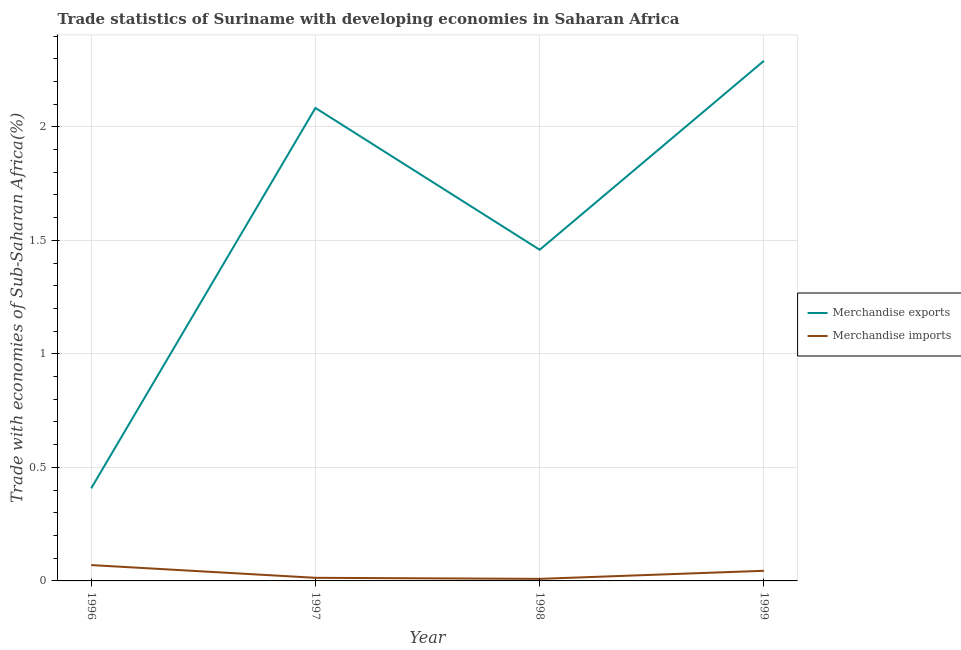What is the merchandise imports in 1998?
Offer a very short reply. 0.01. Across all years, what is the maximum merchandise imports?
Provide a short and direct response. 0.07. Across all years, what is the minimum merchandise exports?
Provide a short and direct response. 0.41. In which year was the merchandise exports minimum?
Keep it short and to the point. 1996. What is the total merchandise imports in the graph?
Give a very brief answer. 0.14. What is the difference between the merchandise imports in 1996 and that in 1997?
Keep it short and to the point. 0.06. What is the difference between the merchandise exports in 1999 and the merchandise imports in 1997?
Keep it short and to the point. 2.28. What is the average merchandise imports per year?
Provide a succinct answer. 0.03. In the year 1997, what is the difference between the merchandise imports and merchandise exports?
Offer a terse response. -2.07. In how many years, is the merchandise imports greater than 0.8 %?
Provide a short and direct response. 0. What is the ratio of the merchandise imports in 1996 to that in 1997?
Your answer should be compact. 5.1. Is the merchandise exports in 1998 less than that in 1999?
Provide a short and direct response. Yes. What is the difference between the highest and the second highest merchandise imports?
Offer a terse response. 0.03. What is the difference between the highest and the lowest merchandise exports?
Give a very brief answer. 1.88. In how many years, is the merchandise exports greater than the average merchandise exports taken over all years?
Give a very brief answer. 2. Does the merchandise imports monotonically increase over the years?
Your response must be concise. No. How many lines are there?
Offer a very short reply. 2. How many years are there in the graph?
Offer a terse response. 4. What is the difference between two consecutive major ticks on the Y-axis?
Provide a short and direct response. 0.5. Does the graph contain grids?
Ensure brevity in your answer.  Yes. How are the legend labels stacked?
Your answer should be very brief. Vertical. What is the title of the graph?
Make the answer very short. Trade statistics of Suriname with developing economies in Saharan Africa. What is the label or title of the X-axis?
Keep it short and to the point. Year. What is the label or title of the Y-axis?
Offer a very short reply. Trade with economies of Sub-Saharan Africa(%). What is the Trade with economies of Sub-Saharan Africa(%) of Merchandise exports in 1996?
Provide a short and direct response. 0.41. What is the Trade with economies of Sub-Saharan Africa(%) of Merchandise imports in 1996?
Your answer should be compact. 0.07. What is the Trade with economies of Sub-Saharan Africa(%) in Merchandise exports in 1997?
Keep it short and to the point. 2.08. What is the Trade with economies of Sub-Saharan Africa(%) of Merchandise imports in 1997?
Provide a succinct answer. 0.01. What is the Trade with economies of Sub-Saharan Africa(%) of Merchandise exports in 1998?
Offer a terse response. 1.46. What is the Trade with economies of Sub-Saharan Africa(%) of Merchandise imports in 1998?
Provide a short and direct response. 0.01. What is the Trade with economies of Sub-Saharan Africa(%) in Merchandise exports in 1999?
Make the answer very short. 2.29. What is the Trade with economies of Sub-Saharan Africa(%) in Merchandise imports in 1999?
Provide a succinct answer. 0.04. Across all years, what is the maximum Trade with economies of Sub-Saharan Africa(%) of Merchandise exports?
Give a very brief answer. 2.29. Across all years, what is the maximum Trade with economies of Sub-Saharan Africa(%) of Merchandise imports?
Offer a very short reply. 0.07. Across all years, what is the minimum Trade with economies of Sub-Saharan Africa(%) of Merchandise exports?
Your response must be concise. 0.41. Across all years, what is the minimum Trade with economies of Sub-Saharan Africa(%) in Merchandise imports?
Your response must be concise. 0.01. What is the total Trade with economies of Sub-Saharan Africa(%) in Merchandise exports in the graph?
Your answer should be very brief. 6.24. What is the total Trade with economies of Sub-Saharan Africa(%) of Merchandise imports in the graph?
Provide a short and direct response. 0.14. What is the difference between the Trade with economies of Sub-Saharan Africa(%) in Merchandise exports in 1996 and that in 1997?
Your response must be concise. -1.68. What is the difference between the Trade with economies of Sub-Saharan Africa(%) in Merchandise imports in 1996 and that in 1997?
Keep it short and to the point. 0.06. What is the difference between the Trade with economies of Sub-Saharan Africa(%) of Merchandise exports in 1996 and that in 1998?
Your answer should be very brief. -1.05. What is the difference between the Trade with economies of Sub-Saharan Africa(%) in Merchandise imports in 1996 and that in 1998?
Offer a terse response. 0.06. What is the difference between the Trade with economies of Sub-Saharan Africa(%) of Merchandise exports in 1996 and that in 1999?
Your answer should be very brief. -1.88. What is the difference between the Trade with economies of Sub-Saharan Africa(%) in Merchandise imports in 1996 and that in 1999?
Give a very brief answer. 0.03. What is the difference between the Trade with economies of Sub-Saharan Africa(%) in Merchandise exports in 1997 and that in 1998?
Offer a very short reply. 0.62. What is the difference between the Trade with economies of Sub-Saharan Africa(%) of Merchandise imports in 1997 and that in 1998?
Offer a terse response. 0. What is the difference between the Trade with economies of Sub-Saharan Africa(%) in Merchandise exports in 1997 and that in 1999?
Your response must be concise. -0.21. What is the difference between the Trade with economies of Sub-Saharan Africa(%) of Merchandise imports in 1997 and that in 1999?
Your answer should be very brief. -0.03. What is the difference between the Trade with economies of Sub-Saharan Africa(%) of Merchandise exports in 1998 and that in 1999?
Offer a very short reply. -0.83. What is the difference between the Trade with economies of Sub-Saharan Africa(%) of Merchandise imports in 1998 and that in 1999?
Provide a short and direct response. -0.04. What is the difference between the Trade with economies of Sub-Saharan Africa(%) in Merchandise exports in 1996 and the Trade with economies of Sub-Saharan Africa(%) in Merchandise imports in 1997?
Keep it short and to the point. 0.39. What is the difference between the Trade with economies of Sub-Saharan Africa(%) in Merchandise exports in 1996 and the Trade with economies of Sub-Saharan Africa(%) in Merchandise imports in 1998?
Provide a succinct answer. 0.4. What is the difference between the Trade with economies of Sub-Saharan Africa(%) in Merchandise exports in 1996 and the Trade with economies of Sub-Saharan Africa(%) in Merchandise imports in 1999?
Your answer should be compact. 0.36. What is the difference between the Trade with economies of Sub-Saharan Africa(%) of Merchandise exports in 1997 and the Trade with economies of Sub-Saharan Africa(%) of Merchandise imports in 1998?
Your answer should be very brief. 2.07. What is the difference between the Trade with economies of Sub-Saharan Africa(%) in Merchandise exports in 1997 and the Trade with economies of Sub-Saharan Africa(%) in Merchandise imports in 1999?
Offer a terse response. 2.04. What is the difference between the Trade with economies of Sub-Saharan Africa(%) in Merchandise exports in 1998 and the Trade with economies of Sub-Saharan Africa(%) in Merchandise imports in 1999?
Make the answer very short. 1.41. What is the average Trade with economies of Sub-Saharan Africa(%) in Merchandise exports per year?
Your answer should be very brief. 1.56. What is the average Trade with economies of Sub-Saharan Africa(%) in Merchandise imports per year?
Offer a very short reply. 0.03. In the year 1996, what is the difference between the Trade with economies of Sub-Saharan Africa(%) of Merchandise exports and Trade with economies of Sub-Saharan Africa(%) of Merchandise imports?
Make the answer very short. 0.34. In the year 1997, what is the difference between the Trade with economies of Sub-Saharan Africa(%) in Merchandise exports and Trade with economies of Sub-Saharan Africa(%) in Merchandise imports?
Offer a terse response. 2.07. In the year 1998, what is the difference between the Trade with economies of Sub-Saharan Africa(%) in Merchandise exports and Trade with economies of Sub-Saharan Africa(%) in Merchandise imports?
Offer a terse response. 1.45. In the year 1999, what is the difference between the Trade with economies of Sub-Saharan Africa(%) in Merchandise exports and Trade with economies of Sub-Saharan Africa(%) in Merchandise imports?
Offer a terse response. 2.25. What is the ratio of the Trade with economies of Sub-Saharan Africa(%) in Merchandise exports in 1996 to that in 1997?
Keep it short and to the point. 0.2. What is the ratio of the Trade with economies of Sub-Saharan Africa(%) in Merchandise imports in 1996 to that in 1997?
Your response must be concise. 5.1. What is the ratio of the Trade with economies of Sub-Saharan Africa(%) of Merchandise exports in 1996 to that in 1998?
Your answer should be very brief. 0.28. What is the ratio of the Trade with economies of Sub-Saharan Africa(%) of Merchandise imports in 1996 to that in 1998?
Ensure brevity in your answer.  7.7. What is the ratio of the Trade with economies of Sub-Saharan Africa(%) in Merchandise exports in 1996 to that in 1999?
Provide a succinct answer. 0.18. What is the ratio of the Trade with economies of Sub-Saharan Africa(%) in Merchandise imports in 1996 to that in 1999?
Give a very brief answer. 1.56. What is the ratio of the Trade with economies of Sub-Saharan Africa(%) of Merchandise exports in 1997 to that in 1998?
Offer a terse response. 1.43. What is the ratio of the Trade with economies of Sub-Saharan Africa(%) in Merchandise imports in 1997 to that in 1998?
Give a very brief answer. 1.51. What is the ratio of the Trade with economies of Sub-Saharan Africa(%) of Merchandise exports in 1997 to that in 1999?
Your answer should be compact. 0.91. What is the ratio of the Trade with economies of Sub-Saharan Africa(%) in Merchandise imports in 1997 to that in 1999?
Offer a very short reply. 0.31. What is the ratio of the Trade with economies of Sub-Saharan Africa(%) of Merchandise exports in 1998 to that in 1999?
Ensure brevity in your answer.  0.64. What is the ratio of the Trade with economies of Sub-Saharan Africa(%) of Merchandise imports in 1998 to that in 1999?
Ensure brevity in your answer.  0.2. What is the difference between the highest and the second highest Trade with economies of Sub-Saharan Africa(%) of Merchandise exports?
Make the answer very short. 0.21. What is the difference between the highest and the second highest Trade with economies of Sub-Saharan Africa(%) in Merchandise imports?
Offer a terse response. 0.03. What is the difference between the highest and the lowest Trade with economies of Sub-Saharan Africa(%) of Merchandise exports?
Your answer should be compact. 1.88. What is the difference between the highest and the lowest Trade with economies of Sub-Saharan Africa(%) of Merchandise imports?
Provide a short and direct response. 0.06. 